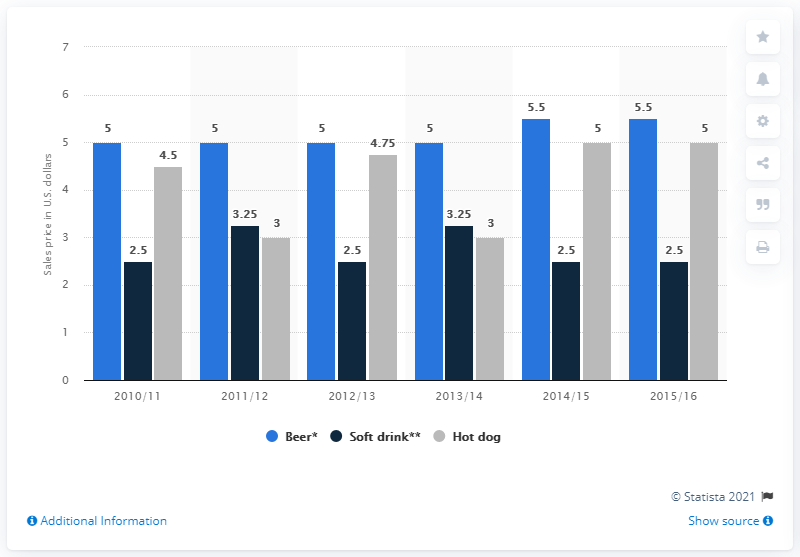List a handful of essential elements in this visual. The price of hot dogs fluctuated from 2010/11 to 2015/16, with a significant increase of 0.5 dollars. In 2014/2015, the price for beer was 5.5. 